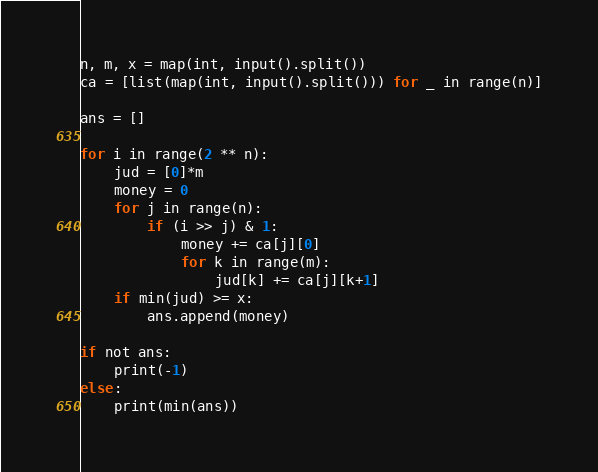Convert code to text. <code><loc_0><loc_0><loc_500><loc_500><_Python_>n, m, x = map(int, input().split())
ca = [list(map(int, input().split())) for _ in range(n)]

ans = []

for i in range(2 ** n):
    jud = [0]*m
    money = 0
    for j in range(n):
        if (i >> j) & 1:
            money += ca[j][0]
            for k in range(m):
                jud[k] += ca[j][k+1]
    if min(jud) >= x:
        ans.append(money)

if not ans:
    print(-1)
else:
    print(min(ans))</code> 